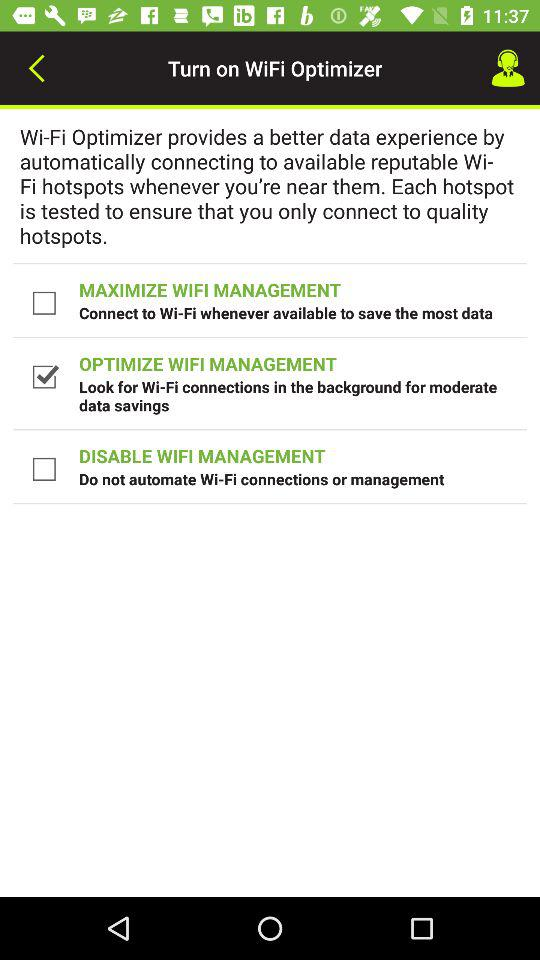How many checkbox options are there?
Answer the question using a single word or phrase. 3 